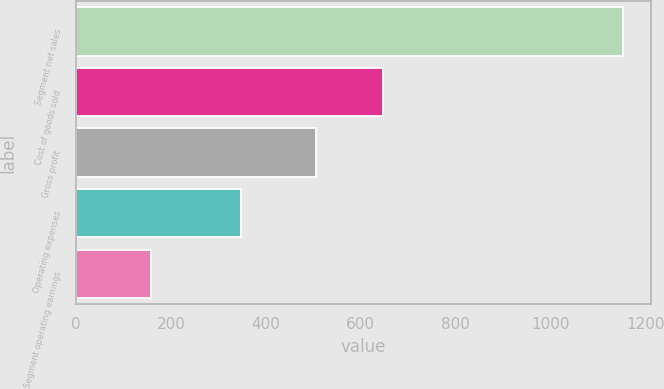Convert chart. <chart><loc_0><loc_0><loc_500><loc_500><bar_chart><fcel>Segment net sales<fcel>Cost of goods sold<fcel>Gross profit<fcel>Operating expenses<fcel>Segment operating earnings<nl><fcel>1153.4<fcel>647<fcel>506.4<fcel>347.9<fcel>158.5<nl></chart> 